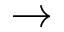<formula> <loc_0><loc_0><loc_500><loc_500>\rightarrow</formula> 